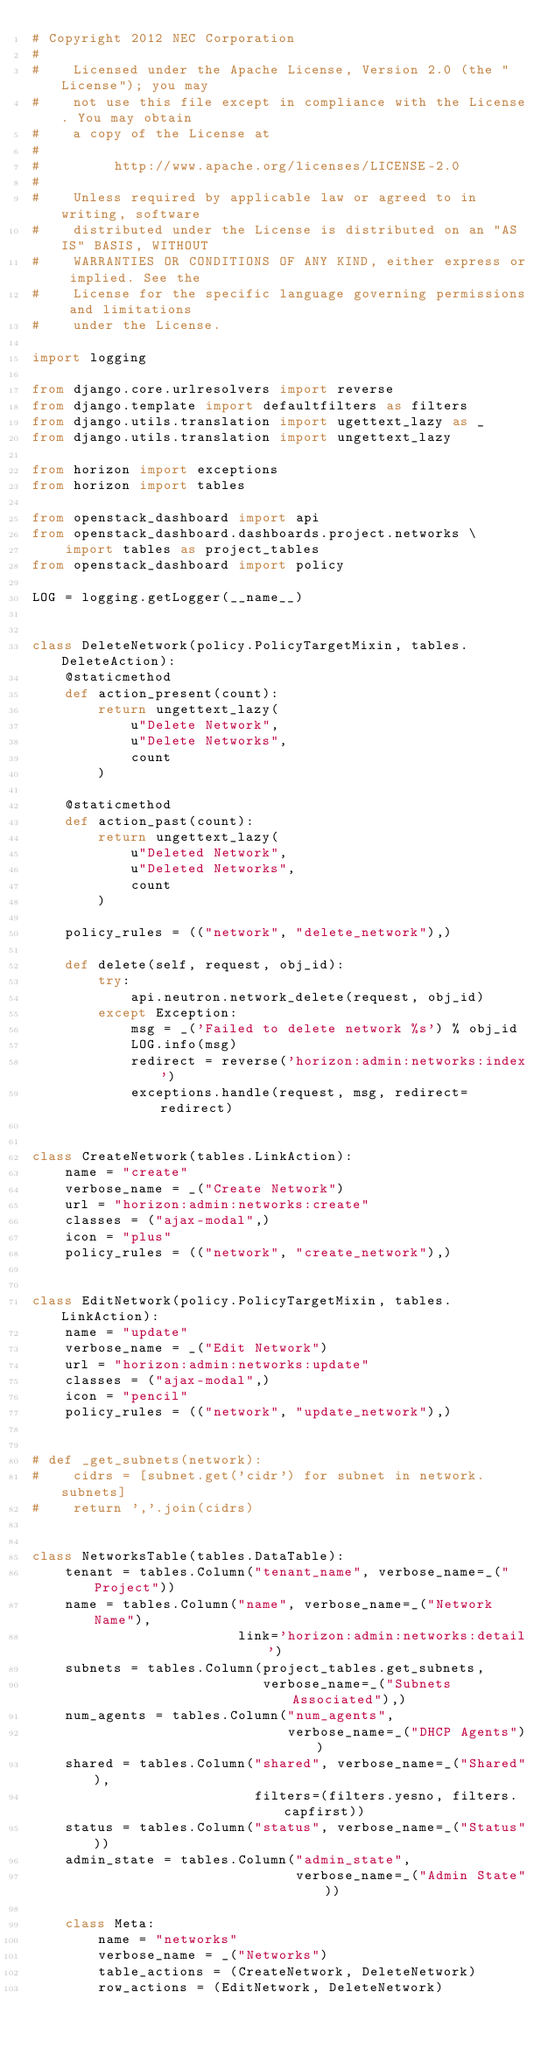Convert code to text. <code><loc_0><loc_0><loc_500><loc_500><_Python_># Copyright 2012 NEC Corporation
#
#    Licensed under the Apache License, Version 2.0 (the "License"); you may
#    not use this file except in compliance with the License. You may obtain
#    a copy of the License at
#
#         http://www.apache.org/licenses/LICENSE-2.0
#
#    Unless required by applicable law or agreed to in writing, software
#    distributed under the License is distributed on an "AS IS" BASIS, WITHOUT
#    WARRANTIES OR CONDITIONS OF ANY KIND, either express or implied. See the
#    License for the specific language governing permissions and limitations
#    under the License.

import logging

from django.core.urlresolvers import reverse
from django.template import defaultfilters as filters
from django.utils.translation import ugettext_lazy as _
from django.utils.translation import ungettext_lazy

from horizon import exceptions
from horizon import tables

from openstack_dashboard import api
from openstack_dashboard.dashboards.project.networks \
    import tables as project_tables
from openstack_dashboard import policy

LOG = logging.getLogger(__name__)


class DeleteNetwork(policy.PolicyTargetMixin, tables.DeleteAction):
    @staticmethod
    def action_present(count):
        return ungettext_lazy(
            u"Delete Network",
            u"Delete Networks",
            count
        )

    @staticmethod
    def action_past(count):
        return ungettext_lazy(
            u"Deleted Network",
            u"Deleted Networks",
            count
        )

    policy_rules = (("network", "delete_network"),)

    def delete(self, request, obj_id):
        try:
            api.neutron.network_delete(request, obj_id)
        except Exception:
            msg = _('Failed to delete network %s') % obj_id
            LOG.info(msg)
            redirect = reverse('horizon:admin:networks:index')
            exceptions.handle(request, msg, redirect=redirect)


class CreateNetwork(tables.LinkAction):
    name = "create"
    verbose_name = _("Create Network")
    url = "horizon:admin:networks:create"
    classes = ("ajax-modal",)
    icon = "plus"
    policy_rules = (("network", "create_network"),)


class EditNetwork(policy.PolicyTargetMixin, tables.LinkAction):
    name = "update"
    verbose_name = _("Edit Network")
    url = "horizon:admin:networks:update"
    classes = ("ajax-modal",)
    icon = "pencil"
    policy_rules = (("network", "update_network"),)


# def _get_subnets(network):
#    cidrs = [subnet.get('cidr') for subnet in network.subnets]
#    return ','.join(cidrs)


class NetworksTable(tables.DataTable):
    tenant = tables.Column("tenant_name", verbose_name=_("Project"))
    name = tables.Column("name", verbose_name=_("Network Name"),
                         link='horizon:admin:networks:detail')
    subnets = tables.Column(project_tables.get_subnets,
                            verbose_name=_("Subnets Associated"),)
    num_agents = tables.Column("num_agents",
                               verbose_name=_("DHCP Agents"))
    shared = tables.Column("shared", verbose_name=_("Shared"),
                           filters=(filters.yesno, filters.capfirst))
    status = tables.Column("status", verbose_name=_("Status"))
    admin_state = tables.Column("admin_state",
                                verbose_name=_("Admin State"))

    class Meta:
        name = "networks"
        verbose_name = _("Networks")
        table_actions = (CreateNetwork, DeleteNetwork)
        row_actions = (EditNetwork, DeleteNetwork)
</code> 